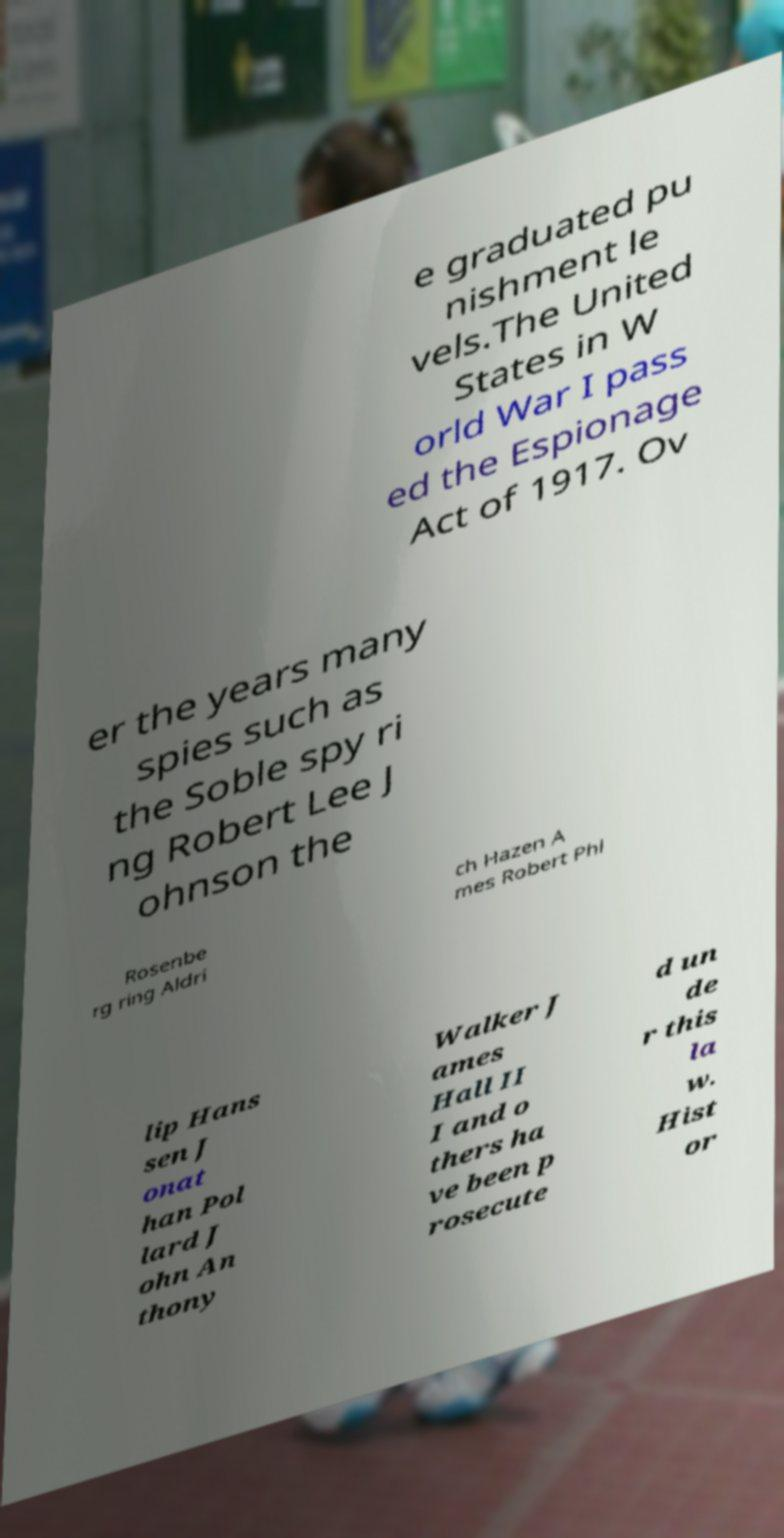There's text embedded in this image that I need extracted. Can you transcribe it verbatim? e graduated pu nishment le vels.The United States in W orld War I pass ed the Espionage Act of 1917. Ov er the years many spies such as the Soble spy ri ng Robert Lee J ohnson the Rosenbe rg ring Aldri ch Hazen A mes Robert Phi lip Hans sen J onat han Pol lard J ohn An thony Walker J ames Hall II I and o thers ha ve been p rosecute d un de r this la w. Hist or 